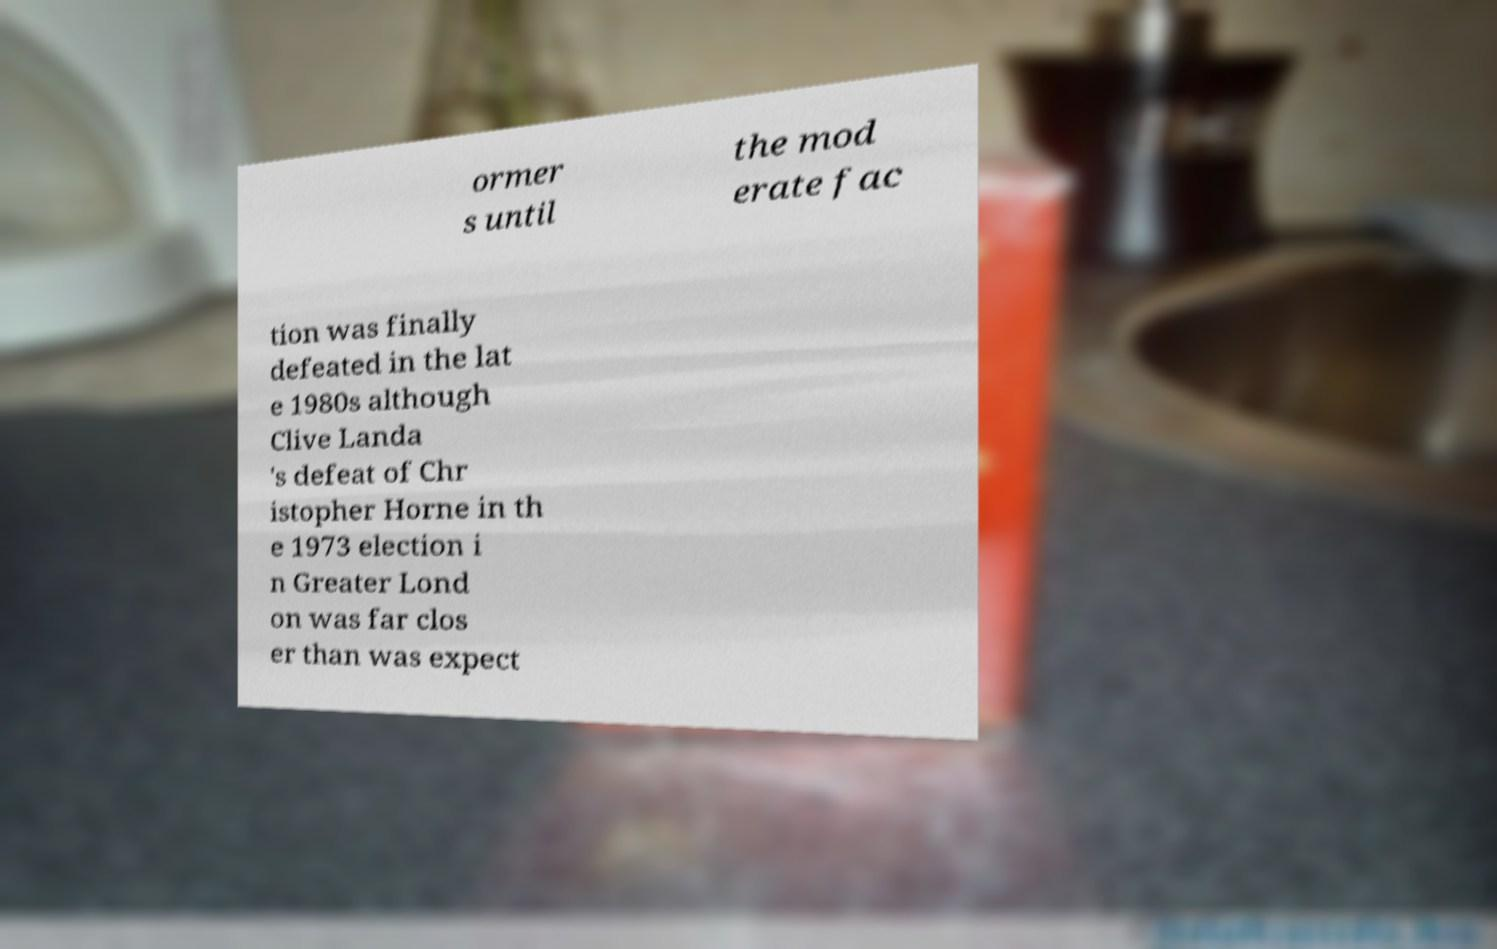Can you accurately transcribe the text from the provided image for me? ormer s until the mod erate fac tion was finally defeated in the lat e 1980s although Clive Landa 's defeat of Chr istopher Horne in th e 1973 election i n Greater Lond on was far clos er than was expect 